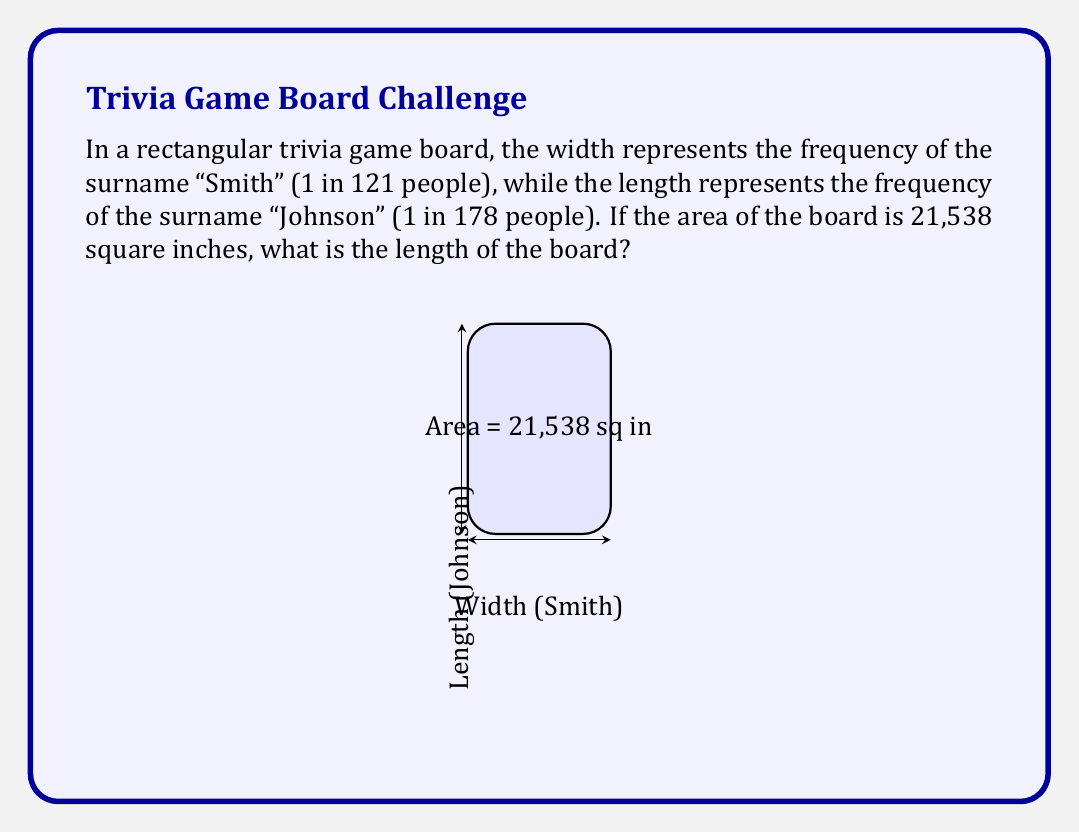What is the answer to this math problem? Let's approach this step-by-step:

1) Let $w$ be the width and $l$ be the length of the board.

2) We know that the ratio of width to length is equal to the ratio of the frequencies:

   $\frac{w}{l} = \frac{1/121}{1/178} = \frac{178}{121}$

3) We can express this as: $w = \frac{178}{121}l$

4) We're given that the area of the board is 21,538 square inches. The area of a rectangle is given by $A = w * l$. So:

   $21,538 = w * l$

5) Substituting our expression for $w$ from step 3:

   $21,538 = (\frac{178}{121}l) * l = \frac{178}{121}l^2$

6) Solving for $l$:

   $l^2 = 21,538 * \frac{121}{178} = 14,634$

   $l = \sqrt{14,634} = 121$

Therefore, the length of the board is 121 inches.
Answer: 121 inches 